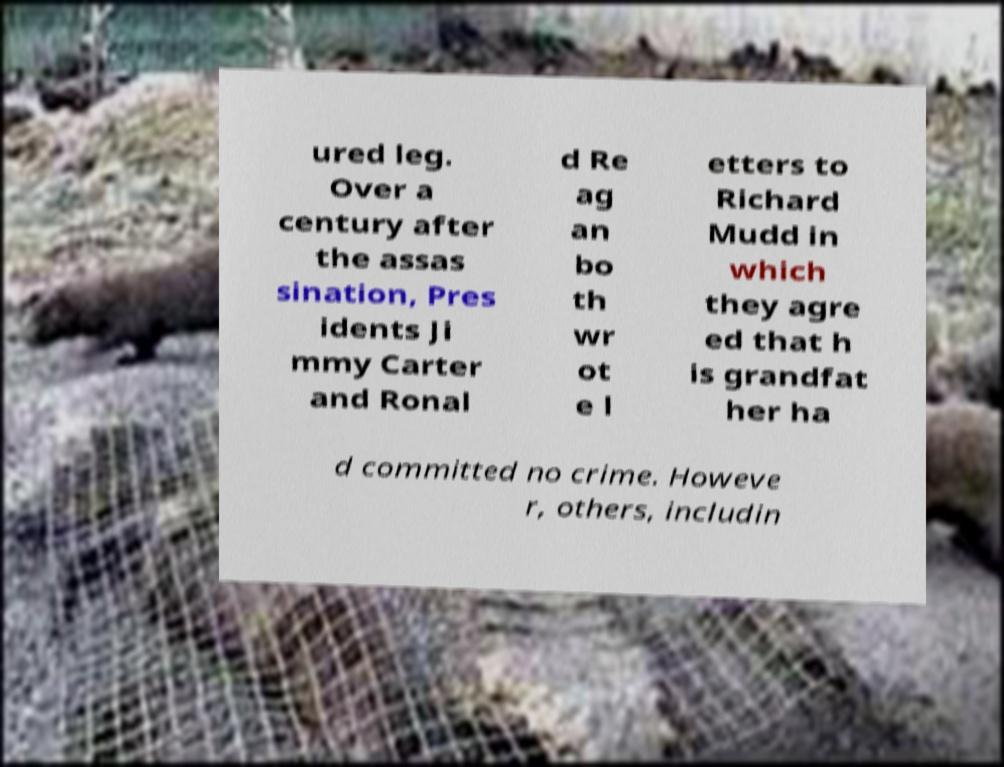Could you extract and type out the text from this image? ured leg. Over a century after the assas sination, Pres idents Ji mmy Carter and Ronal d Re ag an bo th wr ot e l etters to Richard Mudd in which they agre ed that h is grandfat her ha d committed no crime. Howeve r, others, includin 